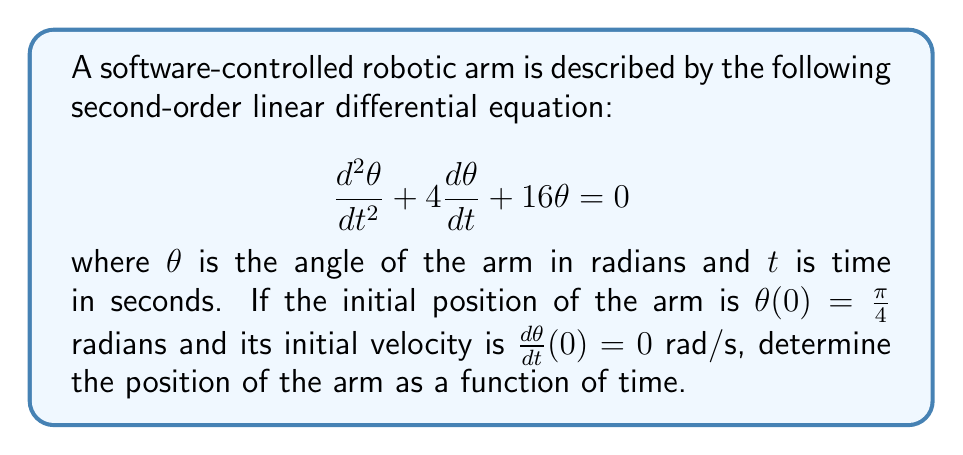Can you solve this math problem? To solve this problem, we'll follow these steps:

1) The characteristic equation for this differential equation is:
   $$r^2 + 4r + 16 = 0$$

2) Solving this quadratic equation:
   $$r = \frac{-4 \pm \sqrt{4^2 - 4(1)(16)}}{2(1)} = \frac{-4 \pm \sqrt{-48}}{2} = -2 \pm 2i\sqrt{3}$$

3) The general solution is therefore:
   $$\theta(t) = e^{-2t}(A\cos(2\sqrt{3}t) + B\sin(2\sqrt{3}t))$$
   where A and B are constants to be determined from the initial conditions.

4) Using the initial condition $\theta(0) = \frac{\pi}{4}$:
   $$\frac{\pi}{4} = A$$

5) For the initial velocity, we differentiate $\theta(t)$:
   $$\frac{d\theta}{dt} = -2e^{-2t}(A\cos(2\sqrt{3}t) + B\sin(2\sqrt{3}t)) + e^{-2t}(-2\sqrt{3}A\sin(2\sqrt{3}t) + 2\sqrt{3}B\cos(2\sqrt{3}t))$$

6) Applying the initial condition $\frac{d\theta}{dt}(0) = 0$:
   $$0 = -2A + 2\sqrt{3}B$$
   $$B = \frac{A}{\sqrt{3}} = \frac{\pi}{4\sqrt{3}}$$

7) Therefore, the solution is:
   $$\theta(t) = e^{-2t}(\frac{\pi}{4}\cos(2\sqrt{3}t) + \frac{\pi}{4\sqrt{3}}\sin(2\sqrt{3}t))$$
Answer: $$\theta(t) = \frac{\pi}{4}e^{-2t}(\cos(2\sqrt{3}t) + \frac{1}{\sqrt{3}}\sin(2\sqrt{3}t))$$ 